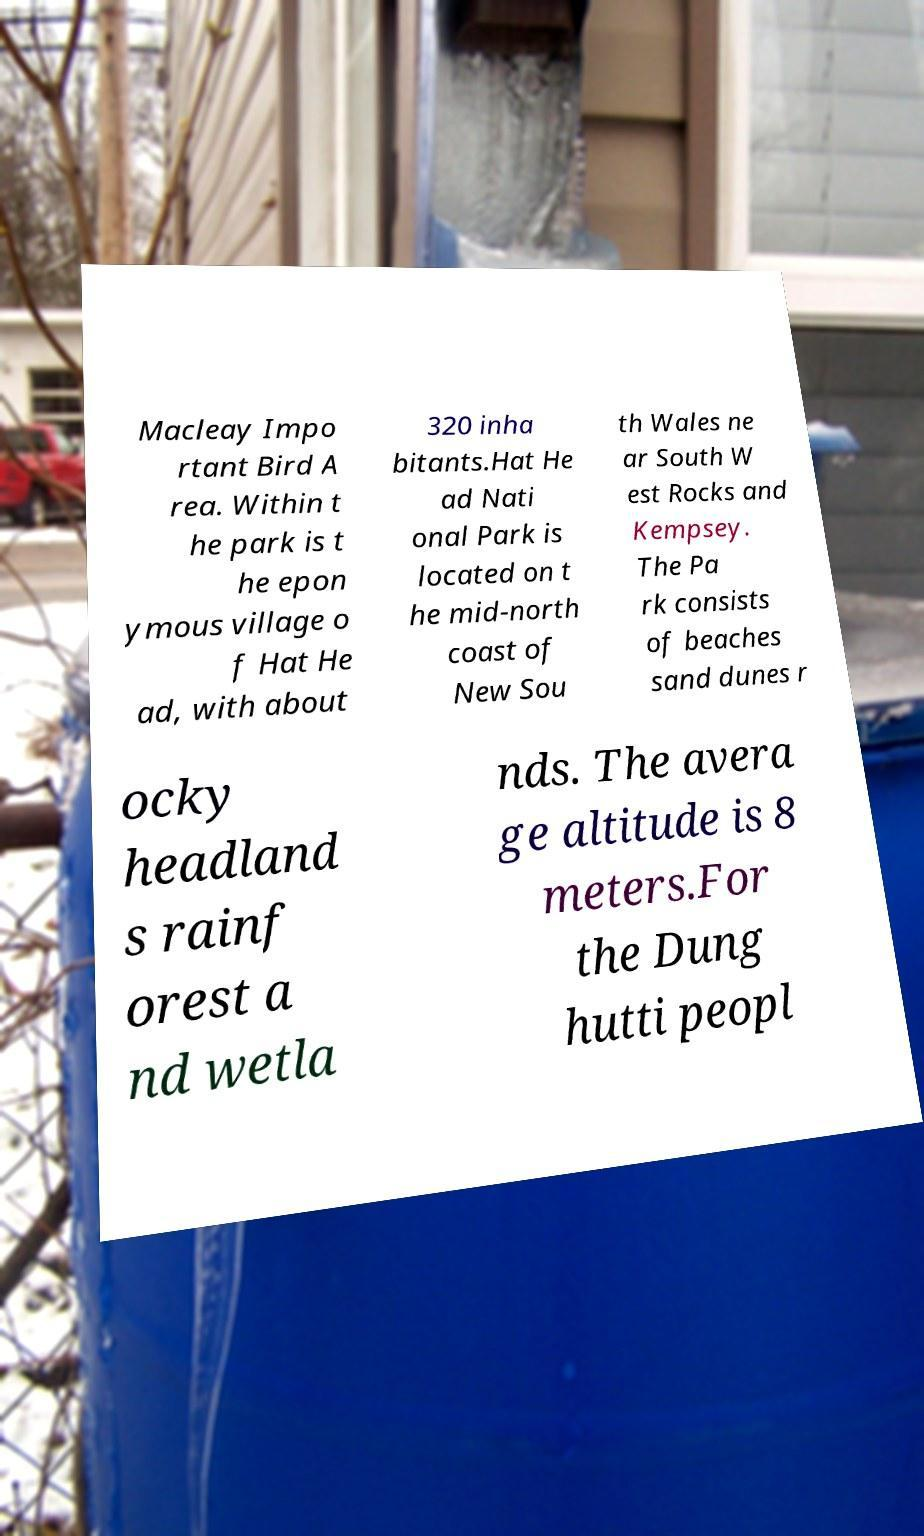Please identify and transcribe the text found in this image. Macleay Impo rtant Bird A rea. Within t he park is t he epon ymous village o f Hat He ad, with about 320 inha bitants.Hat He ad Nati onal Park is located on t he mid-north coast of New Sou th Wales ne ar South W est Rocks and Kempsey. The Pa rk consists of beaches sand dunes r ocky headland s rainf orest a nd wetla nds. The avera ge altitude is 8 meters.For the Dung hutti peopl 